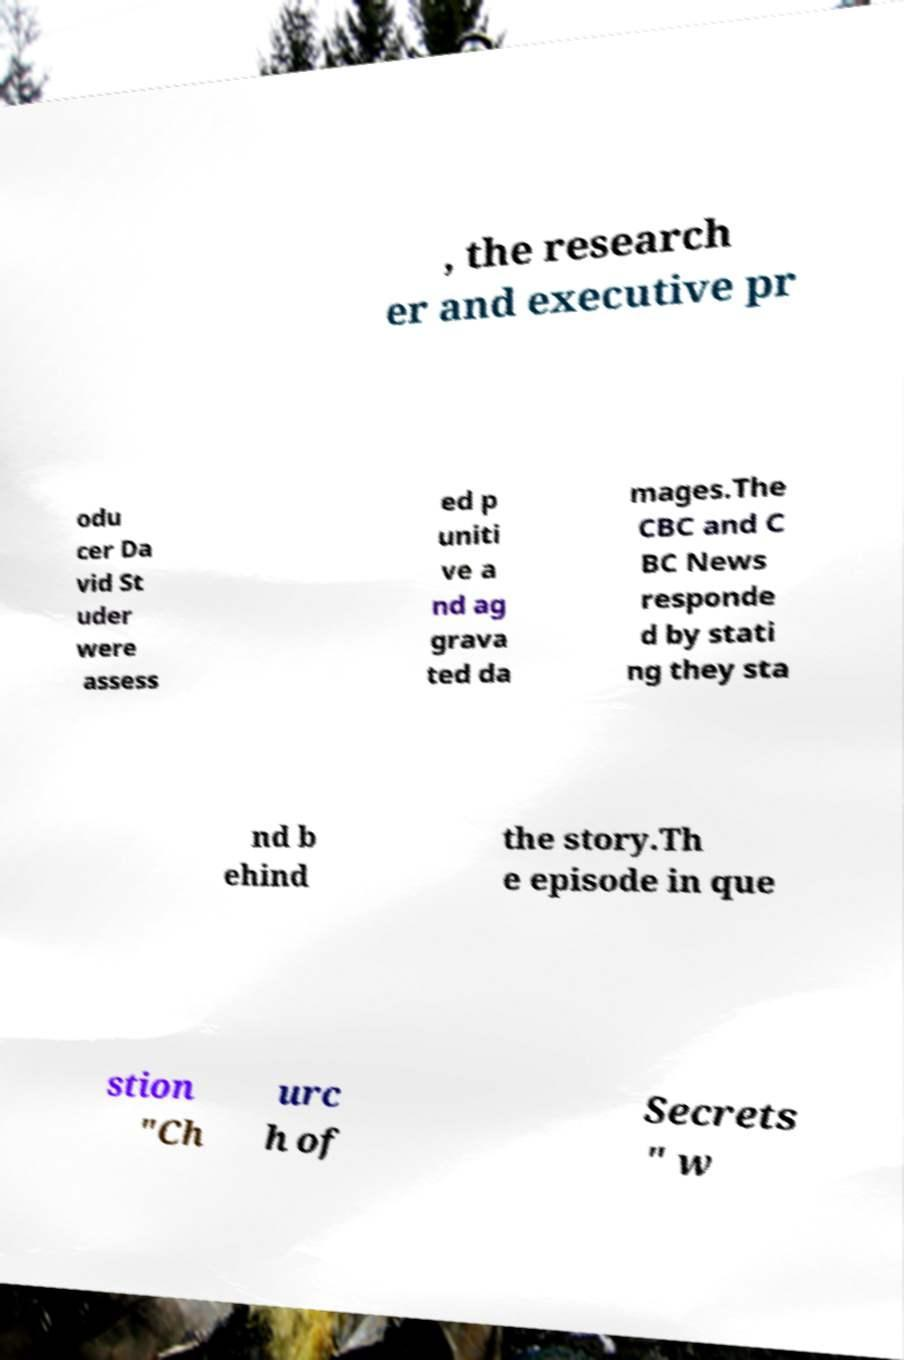For documentation purposes, I need the text within this image transcribed. Could you provide that? , the research er and executive pr odu cer Da vid St uder were assess ed p uniti ve a nd ag grava ted da mages.The CBC and C BC News responde d by stati ng they sta nd b ehind the story.Th e episode in que stion "Ch urc h of Secrets " w 